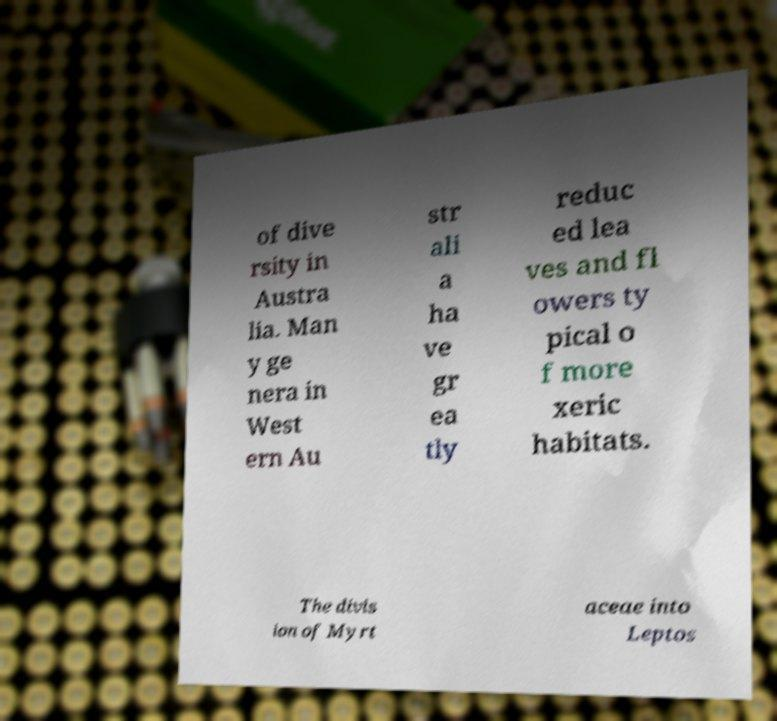Can you read and provide the text displayed in the image?This photo seems to have some interesting text. Can you extract and type it out for me? of dive rsity in Austra lia. Man y ge nera in West ern Au str ali a ha ve gr ea tly reduc ed lea ves and fl owers ty pical o f more xeric habitats. The divis ion of Myrt aceae into Leptos 